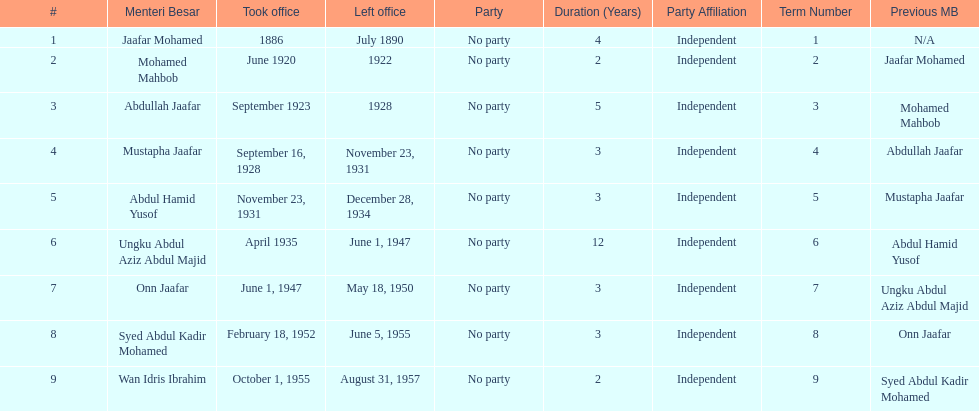Who took office after onn jaafar? Syed Abdul Kadir Mohamed. 